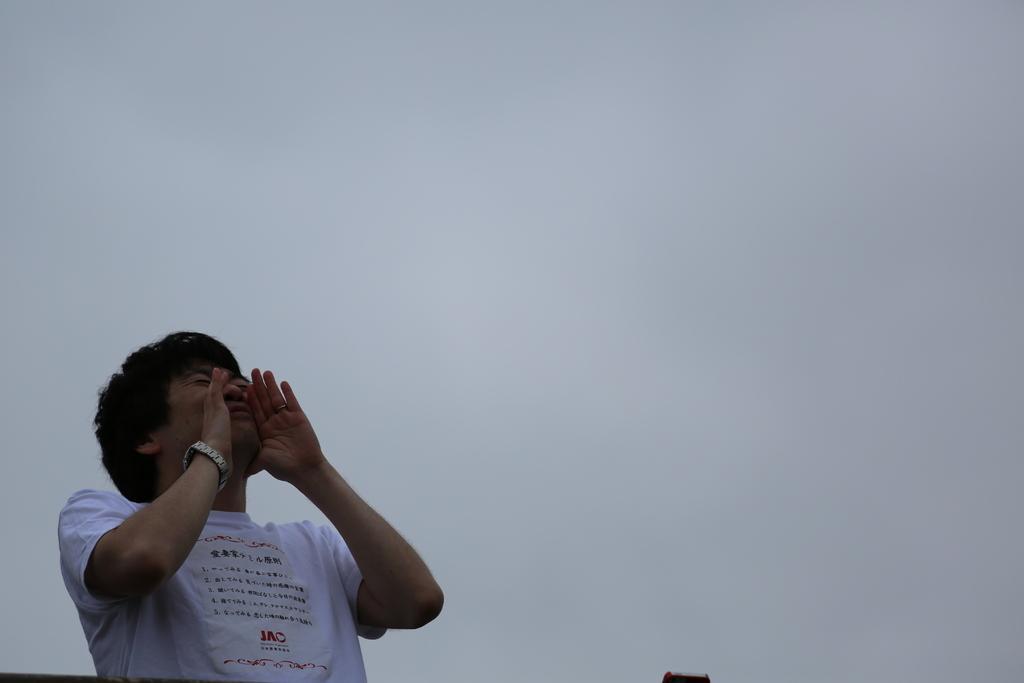Describe this image in one or two sentences. In the image we can see a person. Behind him there is sky. 